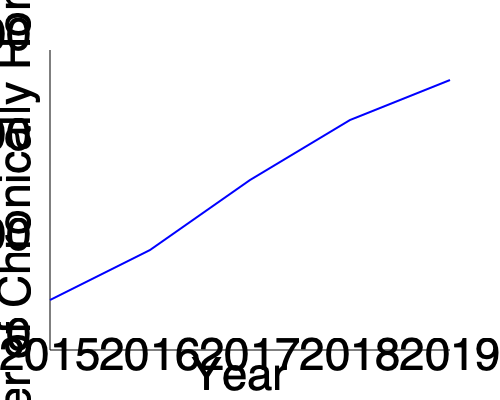Based on the line graph showing the decrease in chronic homelessness over time, what was the approximate percentage reduction in the number of chronically homeless individuals from 2015 to 2019? To calculate the percentage reduction in chronic homelessness from 2015 to 2019:

1. Estimate the number of chronically homeless in 2015 and 2019:
   2015: approximately 12,500
   2019: approximately 3,500

2. Calculate the difference:
   $12,500 - 3,500 = 9,000$

3. Calculate the percentage reduction:
   $\text{Percentage reduction} = \frac{\text{Difference}}{\text{Initial value}} \times 100\%$
   $= \frac{9,000}{12,500} \times 100\%$
   $= 0.72 \times 100\%$
   $= 72\%$

Therefore, the approximate percentage reduction in chronic homelessness from 2015 to 2019 was 72%.
Answer: 72% 